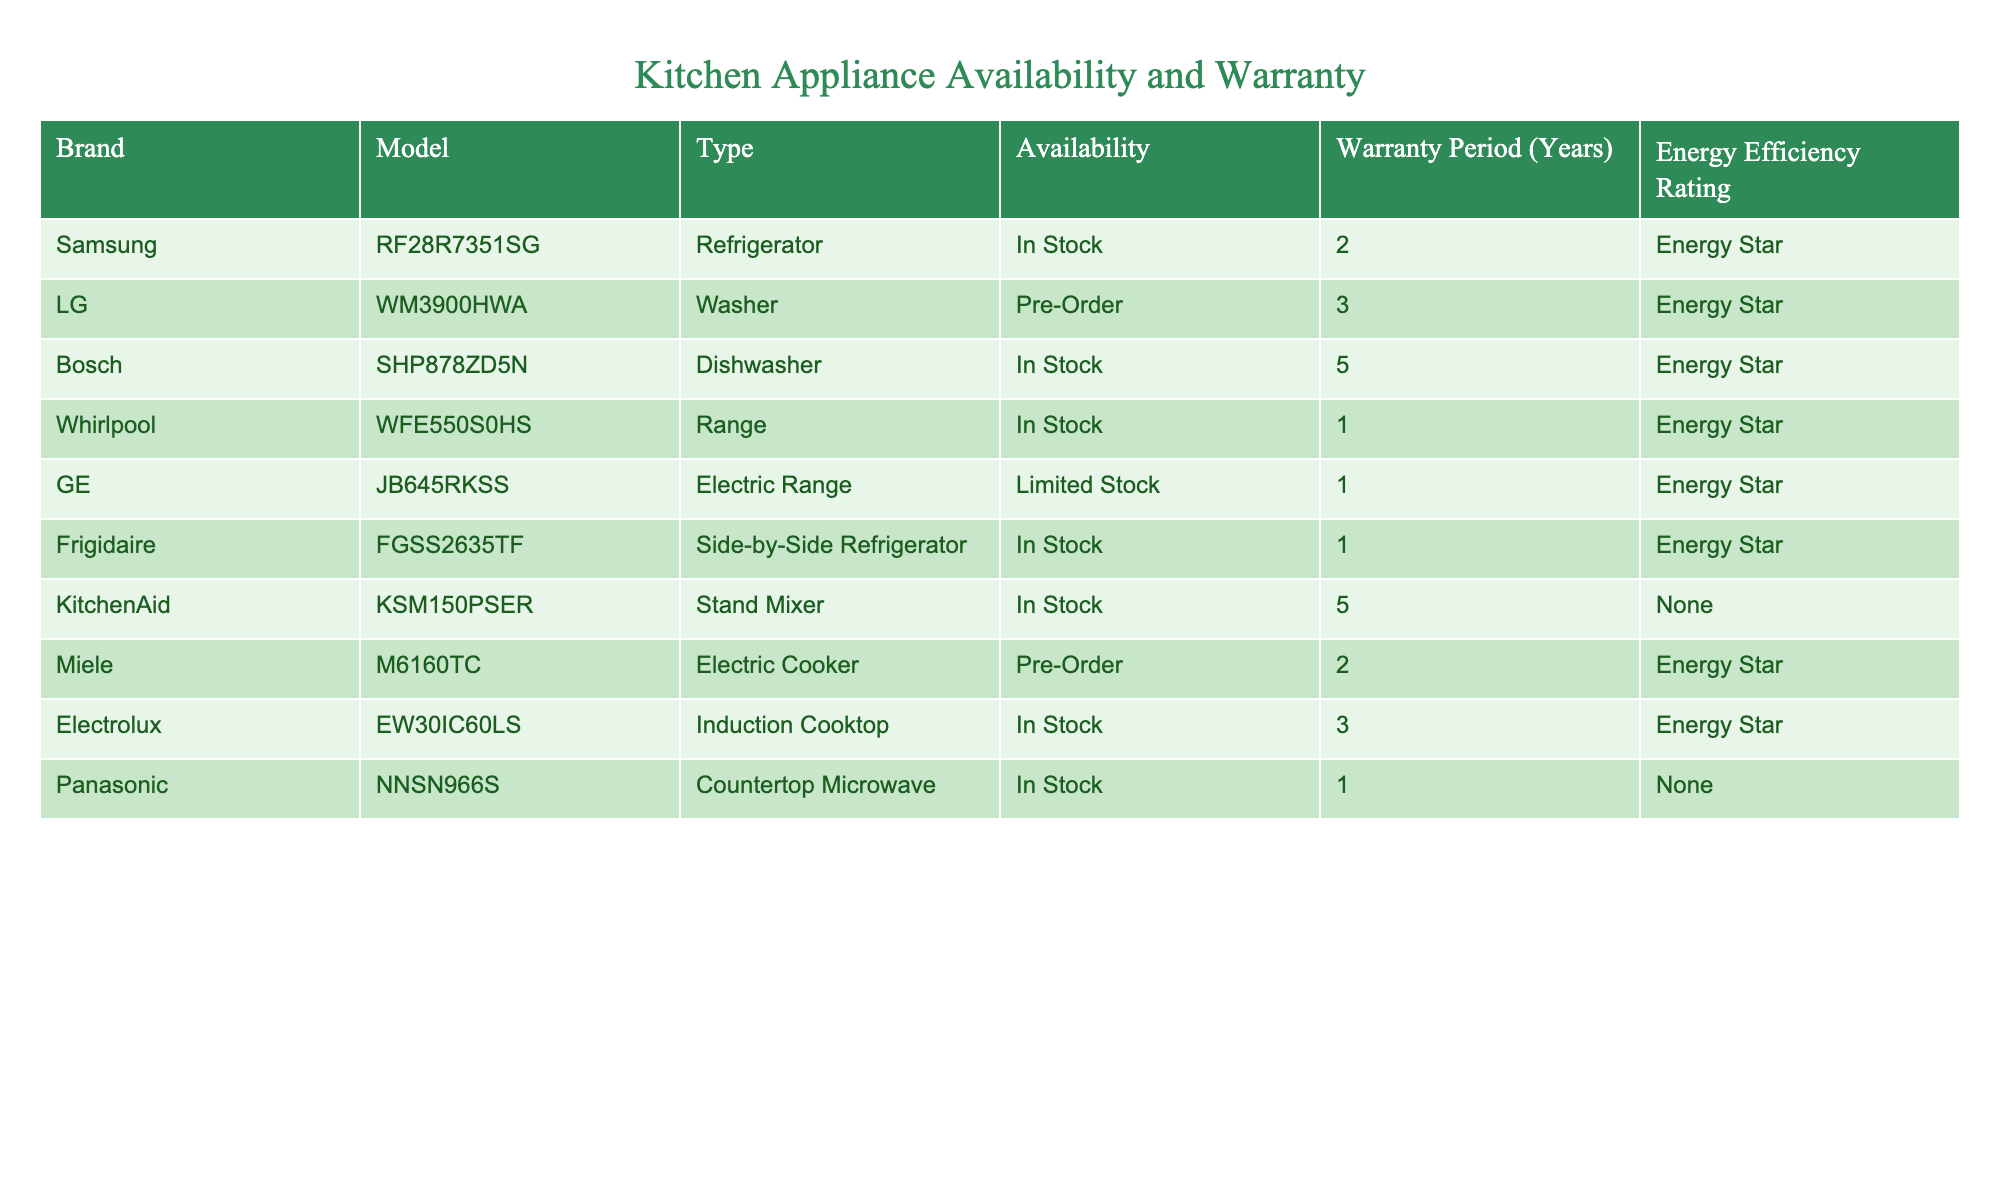What kitchen appliance has the longest warranty period? The warranty periods for each model are as follows: 2 years for Samsung, 3 years for LG, 5 years for Bosch, 1 year for Whirlpool, 1 year for GE, 1 year for Frigidaire, 5 years for KitchenAid, 2 years for Miele, 3 years for Electrolux, and 1 year for Panasonic. The longest warranty period is 5 years, which applies to both Bosch and KitchenAid.
Answer: Bosch and KitchenAid Is the Samsung refrigerator currently available? The table indicates that the Samsung refrigerator model RF28R7351SG is listed under the availability column as "In Stock," which means it is currently available.
Answer: Yes What is the energy efficiency rating for the Frigidaire refrigerator? Referring to the table, the Frigidaire model FGSS2635TF lists "Energy Star" as its energy efficiency rating.
Answer: Energy Star What is the average warranty period of all the kitchen appliances listed? The warranty periods from the table are: 2, 3, 5, 1, 1, 1, 5, 2, 3, and 1 years. Adding these together gives 24 years. Dividing by the total number of appliances (10) results in an average warranty period of 2.4 years.
Answer: 2.4 years Is the LG washer available for immediate purchase? The availability status for the LG model WM3900HWA is "Pre-Order," which indicates it cannot be purchased immediately and must be ordered first.
Answer: No How many appliances have a warranty longer than 2 years? The warranty periods above 2 years are: 3 years for LG, 5 years for Bosch, and 5 years for KitchenAid, making a total of 3 appliances with a warranty longer than 2 years.
Answer: 3 Are there any kitchen appliances that are not energy efficient? According to the table, the energy efficiency ratings for appliances are noted, and both the KitchenAid stand mixer and the Panasonic microwave have "None" listed as their ratings indicating they are not energy efficient.
Answer: Yes Which appliances are currently in stock? The appliances marked as "In Stock" are the Samsung refrigerator, Bosch dishwasher, Whirlpool range, Frigidaire refrigerator, Electrolux induction cooktop, and Panasonic microwave. This totals six appliances currently available for purchase.
Answer: 6 appliances 